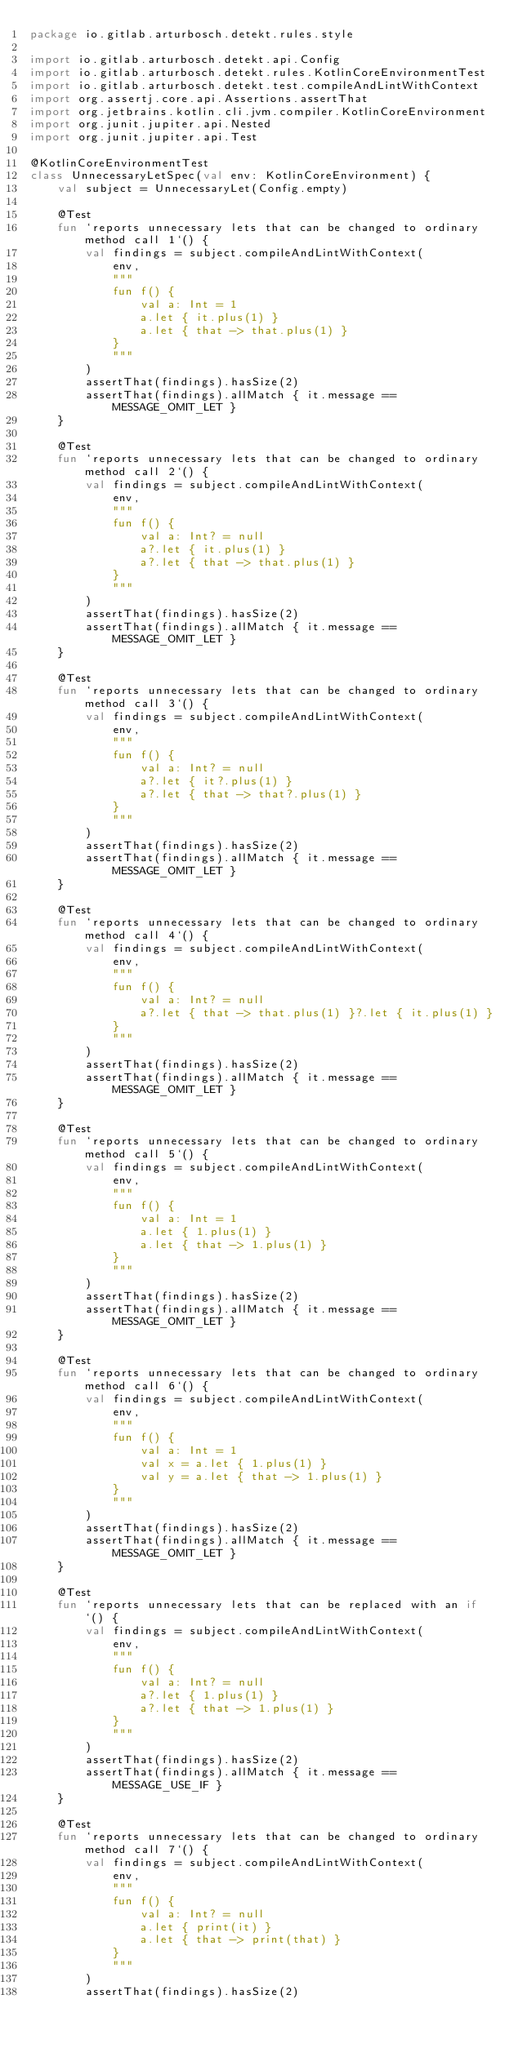<code> <loc_0><loc_0><loc_500><loc_500><_Kotlin_>package io.gitlab.arturbosch.detekt.rules.style

import io.gitlab.arturbosch.detekt.api.Config
import io.gitlab.arturbosch.detekt.rules.KotlinCoreEnvironmentTest
import io.gitlab.arturbosch.detekt.test.compileAndLintWithContext
import org.assertj.core.api.Assertions.assertThat
import org.jetbrains.kotlin.cli.jvm.compiler.KotlinCoreEnvironment
import org.junit.jupiter.api.Nested
import org.junit.jupiter.api.Test

@KotlinCoreEnvironmentTest
class UnnecessaryLetSpec(val env: KotlinCoreEnvironment) {
    val subject = UnnecessaryLet(Config.empty)

    @Test
    fun `reports unnecessary lets that can be changed to ordinary method call 1`() {
        val findings = subject.compileAndLintWithContext(
            env,
            """
            fun f() {
                val a: Int = 1
                a.let { it.plus(1) }
                a.let { that -> that.plus(1) }
            }
            """
        )
        assertThat(findings).hasSize(2)
        assertThat(findings).allMatch { it.message == MESSAGE_OMIT_LET }
    }

    @Test
    fun `reports unnecessary lets that can be changed to ordinary method call 2`() {
        val findings = subject.compileAndLintWithContext(
            env,
            """
            fun f() {
                val a: Int? = null
                a?.let { it.plus(1) }
                a?.let { that -> that.plus(1) }
            }
            """
        )
        assertThat(findings).hasSize(2)
        assertThat(findings).allMatch { it.message == MESSAGE_OMIT_LET }
    }

    @Test
    fun `reports unnecessary lets that can be changed to ordinary method call 3`() {
        val findings = subject.compileAndLintWithContext(
            env,
            """
            fun f() {
                val a: Int? = null
                a?.let { it?.plus(1) }
                a?.let { that -> that?.plus(1) }
            }
            """
        )
        assertThat(findings).hasSize(2)
        assertThat(findings).allMatch { it.message == MESSAGE_OMIT_LET }
    }

    @Test
    fun `reports unnecessary lets that can be changed to ordinary method call 4`() {
        val findings = subject.compileAndLintWithContext(
            env,
            """
            fun f() {
                val a: Int? = null
                a?.let { that -> that.plus(1) }?.let { it.plus(1) }
            }
            """
        )
        assertThat(findings).hasSize(2)
        assertThat(findings).allMatch { it.message == MESSAGE_OMIT_LET }
    }

    @Test
    fun `reports unnecessary lets that can be changed to ordinary method call 5`() {
        val findings = subject.compileAndLintWithContext(
            env,
            """
            fun f() {
                val a: Int = 1
                a.let { 1.plus(1) }
                a.let { that -> 1.plus(1) }
            }
            """
        )
        assertThat(findings).hasSize(2)
        assertThat(findings).allMatch { it.message == MESSAGE_OMIT_LET }
    }

    @Test
    fun `reports unnecessary lets that can be changed to ordinary method call 6`() {
        val findings = subject.compileAndLintWithContext(
            env,
            """
            fun f() {
                val a: Int = 1
                val x = a.let { 1.plus(1) }
                val y = a.let { that -> 1.plus(1) }
            }
            """
        )
        assertThat(findings).hasSize(2)
        assertThat(findings).allMatch { it.message == MESSAGE_OMIT_LET }
    }

    @Test
    fun `reports unnecessary lets that can be replaced with an if`() {
        val findings = subject.compileAndLintWithContext(
            env,
            """
            fun f() {
                val a: Int? = null
                a?.let { 1.plus(1) }
                a?.let { that -> 1.plus(1) }
            }
            """
        )
        assertThat(findings).hasSize(2)
        assertThat(findings).allMatch { it.message == MESSAGE_USE_IF }
    }

    @Test
    fun `reports unnecessary lets that can be changed to ordinary method call 7`() {
        val findings = subject.compileAndLintWithContext(
            env,
            """
            fun f() {
                val a: Int? = null
                a.let { print(it) }
                a.let { that -> print(that) }
            }
            """
        )
        assertThat(findings).hasSize(2)</code> 